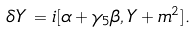Convert formula to latex. <formula><loc_0><loc_0><loc_500><loc_500>\delta Y \, = i [ \alpha + \gamma _ { 5 } \beta , Y + m ^ { 2 } ] .</formula> 